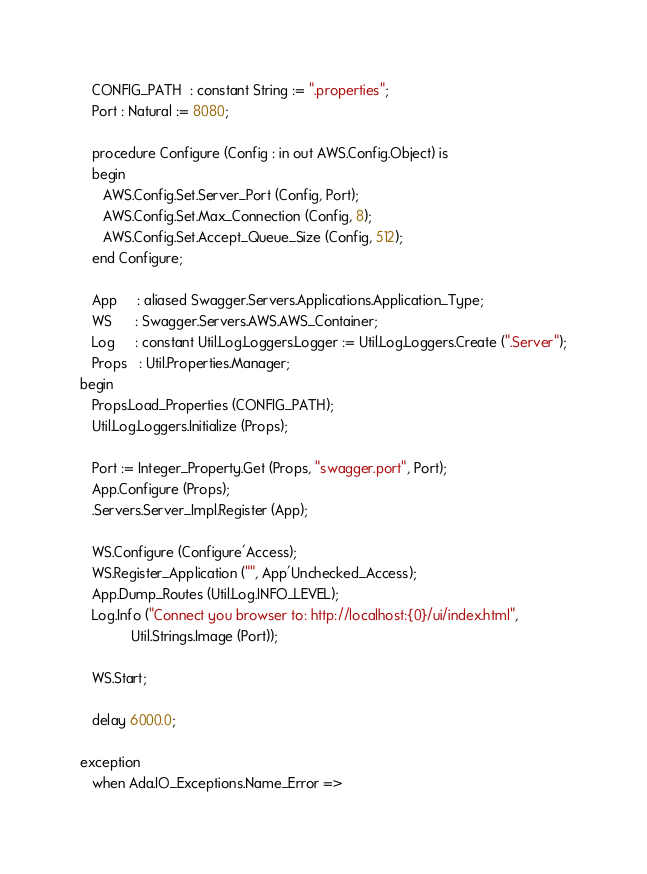<code> <loc_0><loc_0><loc_500><loc_500><_Ada_>   CONFIG_PATH  : constant String := ".properties";
   Port : Natural := 8080;

   procedure Configure (Config : in out AWS.Config.Object) is
   begin
      AWS.Config.Set.Server_Port (Config, Port);
      AWS.Config.Set.Max_Connection (Config, 8);
      AWS.Config.Set.Accept_Queue_Size (Config, 512);
   end Configure;

   App     : aliased Swagger.Servers.Applications.Application_Type;
   WS      : Swagger.Servers.AWS.AWS_Container;
   Log     : constant Util.Log.Loggers.Logger := Util.Log.Loggers.Create (".Server");
   Props   : Util.Properties.Manager;
begin
   Props.Load_Properties (CONFIG_PATH);
   Util.Log.Loggers.Initialize (Props);

   Port := Integer_Property.Get (Props, "swagger.port", Port);
   App.Configure (Props);
   .Servers.Server_Impl.Register (App);

   WS.Configure (Configure'Access);
   WS.Register_Application ("", App'Unchecked_Access);
   App.Dump_Routes (Util.Log.INFO_LEVEL);
   Log.Info ("Connect you browser to: http://localhost:{0}/ui/index.html",
             Util.Strings.Image (Port));

   WS.Start;

   delay 6000.0;

exception
   when Ada.IO_Exceptions.Name_Error =></code> 